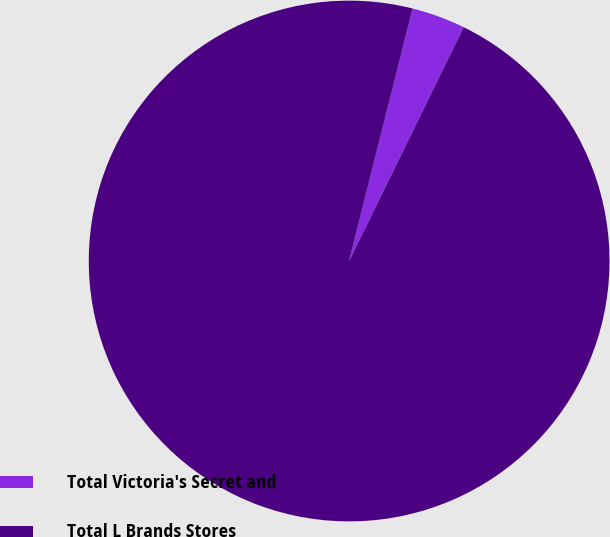Convert chart to OTSL. <chart><loc_0><loc_0><loc_500><loc_500><pie_chart><fcel>Total Victoria's Secret and<fcel>Total L Brands Stores<nl><fcel>3.33%<fcel>96.67%<nl></chart> 